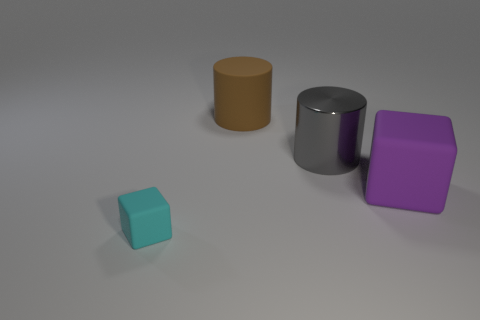Subtract all cyan blocks. Subtract all gray things. How many objects are left? 2 Add 2 purple matte cubes. How many purple matte cubes are left? 3 Add 1 tiny things. How many tiny things exist? 2 Add 1 small purple matte cubes. How many objects exist? 5 Subtract all purple blocks. How many blocks are left? 1 Subtract 0 yellow cubes. How many objects are left? 4 Subtract all red cylinders. Subtract all brown cubes. How many cylinders are left? 2 Subtract all blue cylinders. How many purple cubes are left? 1 